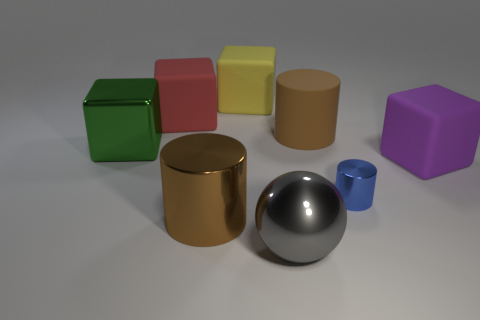There is another cylinder that is the same color as the matte cylinder; what is it made of?
Offer a terse response. Metal. Are there any other things that have the same size as the blue metallic cylinder?
Your answer should be compact. No. There is a large cylinder to the left of the ball; is its color the same as the large cylinder right of the gray metallic sphere?
Your answer should be compact. Yes. There is a shiny thing that is the same shape as the big purple matte thing; what color is it?
Make the answer very short. Green. Is there anything else that has the same shape as the large gray shiny object?
Your answer should be compact. No. Do the object right of the tiny blue object and the large brown rubber object behind the blue cylinder have the same shape?
Provide a succinct answer. No. Does the brown metal thing have the same size as the cube that is behind the red matte cube?
Ensure brevity in your answer.  Yes. Are there more blue cylinders than tiny yellow blocks?
Your answer should be very brief. Yes. Does the brown cylinder that is on the right side of the yellow cube have the same material as the large block that is on the right side of the large gray object?
Your answer should be very brief. Yes. What is the small thing made of?
Your response must be concise. Metal. 